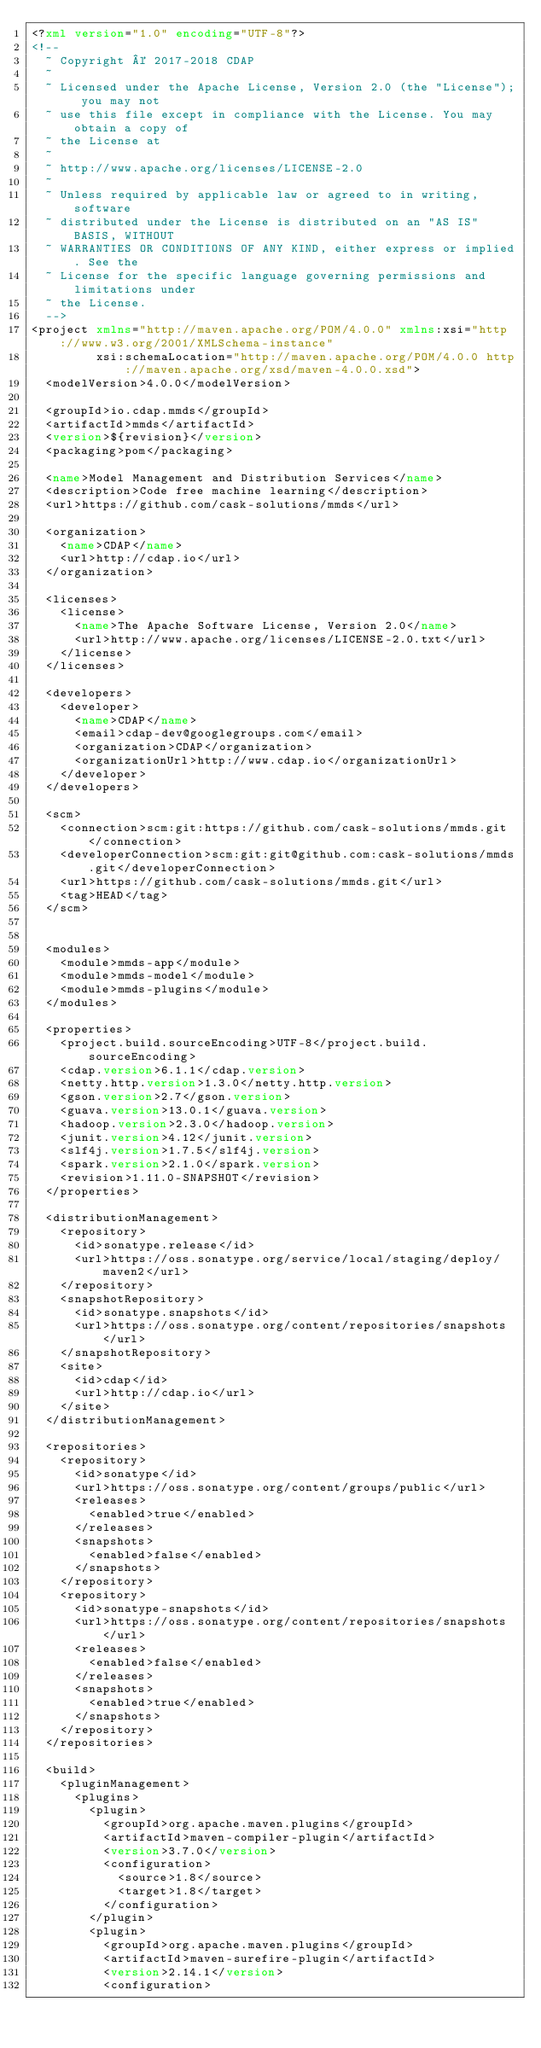<code> <loc_0><loc_0><loc_500><loc_500><_XML_><?xml version="1.0" encoding="UTF-8"?>
<!--
  ~ Copyright © 2017-2018 CDAP
  ~
  ~ Licensed under the Apache License, Version 2.0 (the "License"); you may not
  ~ use this file except in compliance with the License. You may obtain a copy of
  ~ the License at
  ~
  ~ http://www.apache.org/licenses/LICENSE-2.0
  ~
  ~ Unless required by applicable law or agreed to in writing, software
  ~ distributed under the License is distributed on an "AS IS" BASIS, WITHOUT
  ~ WARRANTIES OR CONDITIONS OF ANY KIND, either express or implied. See the
  ~ License for the specific language governing permissions and limitations under
  ~ the License.
  -->
<project xmlns="http://maven.apache.org/POM/4.0.0" xmlns:xsi="http://www.w3.org/2001/XMLSchema-instance"
         xsi:schemaLocation="http://maven.apache.org/POM/4.0.0 http://maven.apache.org/xsd/maven-4.0.0.xsd">
  <modelVersion>4.0.0</modelVersion>

  <groupId>io.cdap.mmds</groupId>
  <artifactId>mmds</artifactId>
  <version>${revision}</version>
  <packaging>pom</packaging>

  <name>Model Management and Distribution Services</name>
  <description>Code free machine learning</description>
  <url>https://github.com/cask-solutions/mmds</url>

  <organization>
    <name>CDAP</name>
    <url>http://cdap.io</url>
  </organization>

  <licenses>
    <license>
      <name>The Apache Software License, Version 2.0</name>
      <url>http://www.apache.org/licenses/LICENSE-2.0.txt</url>
    </license>
  </licenses>

  <developers>
    <developer>
      <name>CDAP</name>
      <email>cdap-dev@googlegroups.com</email>
      <organization>CDAP</organization>
      <organizationUrl>http://www.cdap.io</organizationUrl>
    </developer>
  </developers>

  <scm>
    <connection>scm:git:https://github.com/cask-solutions/mmds.git</connection>
    <developerConnection>scm:git:git@github.com:cask-solutions/mmds.git</developerConnection>
    <url>https://github.com/cask-solutions/mmds.git</url>
    <tag>HEAD</tag>
  </scm>


  <modules>
    <module>mmds-app</module>
    <module>mmds-model</module>
    <module>mmds-plugins</module>
  </modules>

  <properties>
    <project.build.sourceEncoding>UTF-8</project.build.sourceEncoding>
    <cdap.version>6.1.1</cdap.version>
    <netty.http.version>1.3.0</netty.http.version>
    <gson.version>2.7</gson.version>
    <guava.version>13.0.1</guava.version>
    <hadoop.version>2.3.0</hadoop.version>
    <junit.version>4.12</junit.version>
    <slf4j.version>1.7.5</slf4j.version>
    <spark.version>2.1.0</spark.version>
    <revision>1.11.0-SNAPSHOT</revision>
  </properties>

  <distributionManagement>
    <repository>
      <id>sonatype.release</id>
      <url>https://oss.sonatype.org/service/local/staging/deploy/maven2</url>
    </repository>
    <snapshotRepository>
      <id>sonatype.snapshots</id>
      <url>https://oss.sonatype.org/content/repositories/snapshots</url>
    </snapshotRepository>
    <site>
      <id>cdap</id>
      <url>http://cdap.io</url>
    </site>
  </distributionManagement>

  <repositories>
    <repository>
      <id>sonatype</id>
      <url>https://oss.sonatype.org/content/groups/public</url>
      <releases>
        <enabled>true</enabled>
      </releases>
      <snapshots>
        <enabled>false</enabled>
      </snapshots>
    </repository>
    <repository>
      <id>sonatype-snapshots</id>
      <url>https://oss.sonatype.org/content/repositories/snapshots</url>
      <releases>
        <enabled>false</enabled>
      </releases>
      <snapshots>
        <enabled>true</enabled>
      </snapshots>
    </repository>
  </repositories>

  <build>
    <pluginManagement>
      <plugins>
        <plugin>
          <groupId>org.apache.maven.plugins</groupId>
          <artifactId>maven-compiler-plugin</artifactId>
          <version>3.7.0</version>
          <configuration>
            <source>1.8</source>
            <target>1.8</target>
          </configuration>
        </plugin>
        <plugin>
          <groupId>org.apache.maven.plugins</groupId>
          <artifactId>maven-surefire-plugin</artifactId>
          <version>2.14.1</version>
          <configuration></code> 